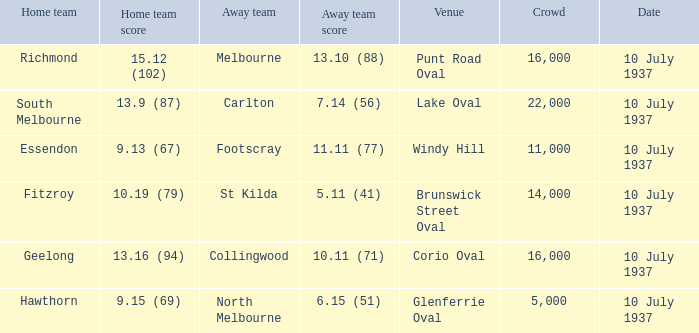What is the lowest Crowd with a Home Team Score of 9.15 (69)? 5000.0. 